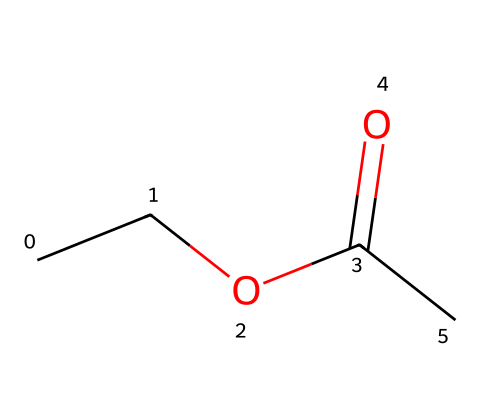What is the molecular formula of ethyl acetate? By analyzing the structure, we see that there are two carbon atoms from the ethyl group (C2), one carbon from the carbonyl group (C1), and two oxygen atoms (O2). Therefore, the molecular formula is C4H8O2.
Answer: C4H8O2 How many carbon atoms are in ethyl acetate? The visual representation indicates that there are four carbon atoms in total: two from the ethyl group and one from the carbonyl group.
Answer: 4 What type of functional group is present in ethyl acetate? The structure displays a carbonyl group (C=O) attached to an alkoxy group (OC), which is characteristic of esters.
Answer: ester What is the primary use of ethyl acetate in sustainable manufacturing? Ethyl acetate is primarily used as a solvent due to its favorable properties such as low toxicity and volatility, making it suitable for sustainable practices.
Answer: solvent Why might ethyl acetate be considered a "green" solvent? Ethyl acetate is biodegradable, has low toxicity to humans and the environment, and is derived from renewable resources, aligning with the principles of green chemistry.
Answer: biodegradable What is the total number of hydrogen atoms in ethyl acetate? Looking at the structure, we see there are eight hydrogen atoms distributed in the ethyl group and the ester structure, totaling eight.
Answer: 8 How many double bonds are present in the molecular structure of ethyl acetate? The chemical structure features one double bond located in the carbonyl group (C=O), which is characteristic of esters.
Answer: 1 